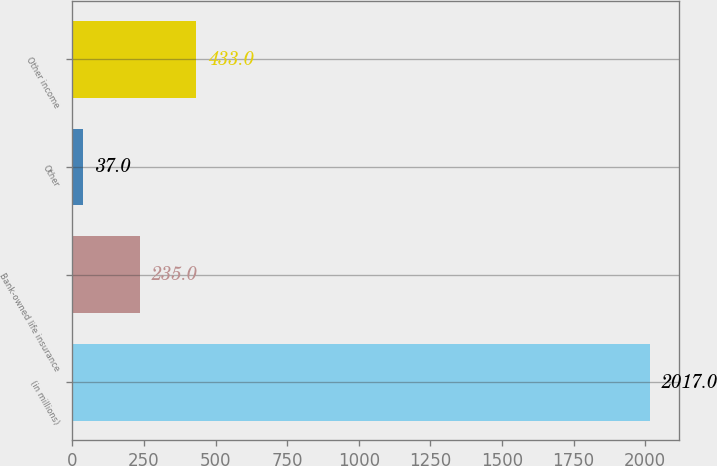<chart> <loc_0><loc_0><loc_500><loc_500><bar_chart><fcel>(in millions)<fcel>Bank-owned life insurance<fcel>Other<fcel>Other income<nl><fcel>2017<fcel>235<fcel>37<fcel>433<nl></chart> 